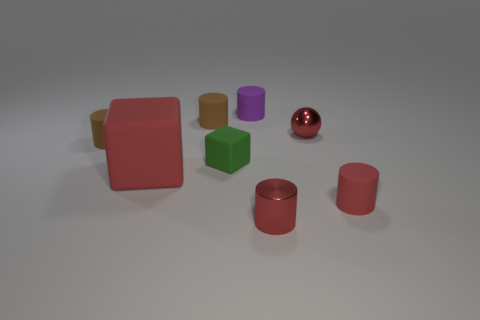Is there any other thing that has the same size as the red block?
Ensure brevity in your answer.  No. There is a metallic thing that is the same size as the red ball; what is its color?
Your response must be concise. Red. There is a brown rubber thing left of the large object; how many small cylinders are to the right of it?
Your response must be concise. 4. How many tiny things are both to the right of the purple cylinder and in front of the red ball?
Give a very brief answer. 2. How many things are small red metallic objects that are in front of the red matte cylinder or red objects that are on the right side of the small green rubber block?
Ensure brevity in your answer.  3. What number of other things are there of the same size as the green cube?
Make the answer very short. 6. The tiny matte thing that is to the right of the small metal thing that is on the left side of the red ball is what shape?
Your answer should be very brief. Cylinder. Is the color of the thing in front of the tiny red matte thing the same as the small metal object that is behind the green rubber cube?
Make the answer very short. Yes. Is there anything else that is the same color as the tiny metallic cylinder?
Your answer should be compact. Yes. What is the color of the large cube?
Provide a succinct answer. Red. 